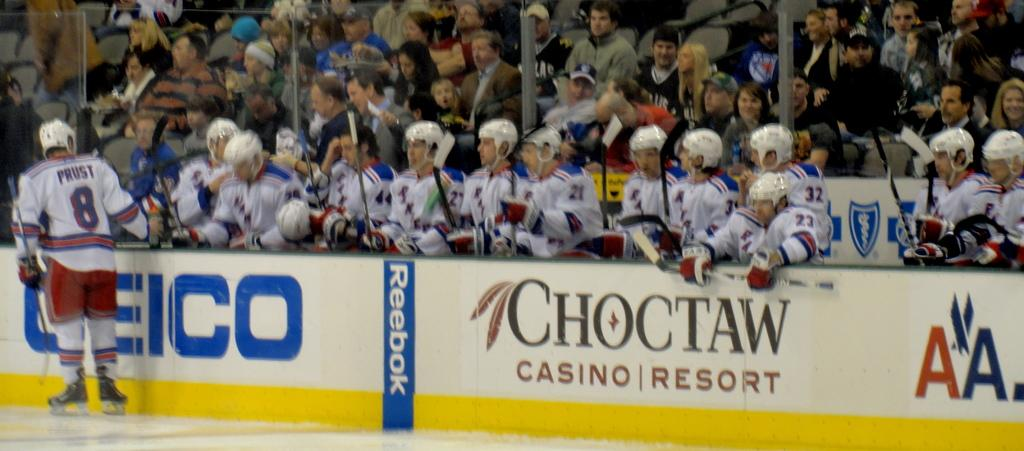<image>
Render a clear and concise summary of the photo. A hockey ring with an advertisement for Geico 